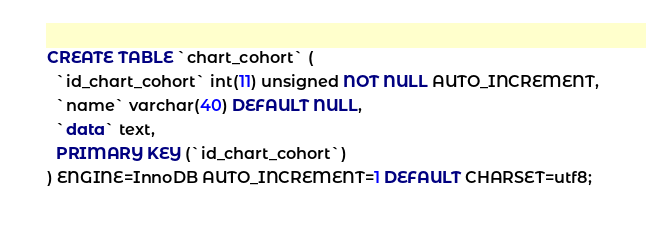Convert code to text. <code><loc_0><loc_0><loc_500><loc_500><_SQL_>CREATE TABLE `chart_cohort` (
  `id_chart_cohort` int(11) unsigned NOT NULL AUTO_INCREMENT,
  `name` varchar(40) DEFAULT NULL,
  `data` text,
  PRIMARY KEY (`id_chart_cohort`)
) ENGINE=InnoDB AUTO_INCREMENT=1 DEFAULT CHARSET=utf8;</code> 